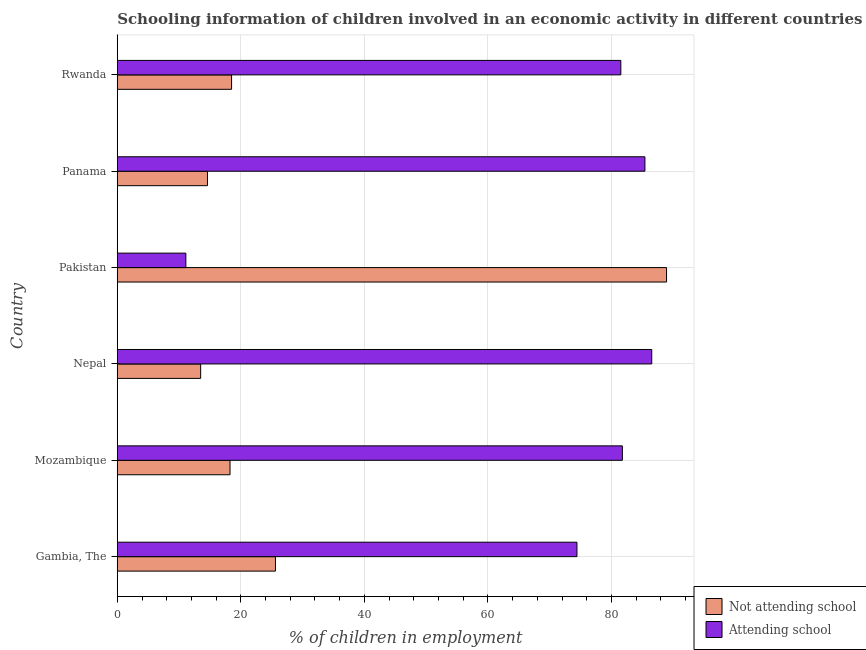How many different coloured bars are there?
Your response must be concise. 2. How many groups of bars are there?
Your response must be concise. 6. What is the label of the 1st group of bars from the top?
Offer a very short reply. Rwanda. Across all countries, what is the maximum percentage of employed children who are attending school?
Make the answer very short. 86.51. Across all countries, what is the minimum percentage of employed children who are not attending school?
Ensure brevity in your answer.  13.49. What is the total percentage of employed children who are attending school in the graph?
Provide a succinct answer. 420.66. What is the difference between the percentage of employed children who are attending school in Gambia, The and that in Mozambique?
Your answer should be compact. -7.35. What is the average percentage of employed children who are not attending school per country?
Ensure brevity in your answer.  29.89. What is the difference between the percentage of employed children who are attending school and percentage of employed children who are not attending school in Gambia, The?
Your answer should be very brief. 48.8. In how many countries, is the percentage of employed children who are not attending school greater than 52 %?
Provide a short and direct response. 1. What is the ratio of the percentage of employed children who are attending school in Gambia, The to that in Panama?
Offer a terse response. 0.87. Is the percentage of employed children who are attending school in Gambia, The less than that in Panama?
Your answer should be compact. Yes. Is the difference between the percentage of employed children who are attending school in Gambia, The and Rwanda greater than the difference between the percentage of employed children who are not attending school in Gambia, The and Rwanda?
Your answer should be compact. No. What is the difference between the highest and the second highest percentage of employed children who are attending school?
Your answer should be compact. 1.11. What is the difference between the highest and the lowest percentage of employed children who are attending school?
Provide a short and direct response. 75.41. Is the sum of the percentage of employed children who are attending school in Mozambique and Rwanda greater than the maximum percentage of employed children who are not attending school across all countries?
Your answer should be compact. Yes. What does the 2nd bar from the top in Panama represents?
Keep it short and to the point. Not attending school. What does the 2nd bar from the bottom in Nepal represents?
Provide a succinct answer. Attending school. How many bars are there?
Provide a short and direct response. 12. Are all the bars in the graph horizontal?
Your response must be concise. Yes. How many countries are there in the graph?
Your response must be concise. 6. What is the difference between two consecutive major ticks on the X-axis?
Provide a short and direct response. 20. Does the graph contain any zero values?
Provide a short and direct response. No. Where does the legend appear in the graph?
Keep it short and to the point. Bottom right. How are the legend labels stacked?
Keep it short and to the point. Vertical. What is the title of the graph?
Your response must be concise. Schooling information of children involved in an economic activity in different countries. Does "Non-residents" appear as one of the legend labels in the graph?
Offer a terse response. No. What is the label or title of the X-axis?
Provide a succinct answer. % of children in employment. What is the label or title of the Y-axis?
Offer a terse response. Country. What is the % of children in employment in Not attending school in Gambia, The?
Keep it short and to the point. 25.6. What is the % of children in employment in Attending school in Gambia, The?
Your response must be concise. 74.4. What is the % of children in employment in Not attending school in Mozambique?
Your answer should be compact. 18.25. What is the % of children in employment of Attending school in Mozambique?
Give a very brief answer. 81.75. What is the % of children in employment of Not attending school in Nepal?
Offer a very short reply. 13.49. What is the % of children in employment of Attending school in Nepal?
Keep it short and to the point. 86.51. What is the % of children in employment in Not attending school in Pakistan?
Keep it short and to the point. 88.9. What is the % of children in employment in Attending school in Panama?
Offer a very short reply. 85.4. What is the % of children in employment of Not attending school in Rwanda?
Provide a short and direct response. 18.5. What is the % of children in employment in Attending school in Rwanda?
Your answer should be compact. 81.5. Across all countries, what is the maximum % of children in employment of Not attending school?
Give a very brief answer. 88.9. Across all countries, what is the maximum % of children in employment in Attending school?
Your response must be concise. 86.51. Across all countries, what is the minimum % of children in employment in Not attending school?
Give a very brief answer. 13.49. What is the total % of children in employment of Not attending school in the graph?
Your answer should be compact. 179.34. What is the total % of children in employment of Attending school in the graph?
Your answer should be very brief. 420.66. What is the difference between the % of children in employment in Not attending school in Gambia, The and that in Mozambique?
Offer a very short reply. 7.35. What is the difference between the % of children in employment in Attending school in Gambia, The and that in Mozambique?
Your response must be concise. -7.35. What is the difference between the % of children in employment in Not attending school in Gambia, The and that in Nepal?
Give a very brief answer. 12.11. What is the difference between the % of children in employment in Attending school in Gambia, The and that in Nepal?
Offer a terse response. -12.11. What is the difference between the % of children in employment of Not attending school in Gambia, The and that in Pakistan?
Offer a terse response. -63.3. What is the difference between the % of children in employment of Attending school in Gambia, The and that in Pakistan?
Provide a short and direct response. 63.3. What is the difference between the % of children in employment of Not attending school in Gambia, The and that in Rwanda?
Make the answer very short. 7.1. What is the difference between the % of children in employment in Not attending school in Mozambique and that in Nepal?
Make the answer very short. 4.75. What is the difference between the % of children in employment in Attending school in Mozambique and that in Nepal?
Ensure brevity in your answer.  -4.75. What is the difference between the % of children in employment in Not attending school in Mozambique and that in Pakistan?
Your answer should be very brief. -70.65. What is the difference between the % of children in employment of Attending school in Mozambique and that in Pakistan?
Provide a short and direct response. 70.65. What is the difference between the % of children in employment of Not attending school in Mozambique and that in Panama?
Provide a short and direct response. 3.65. What is the difference between the % of children in employment of Attending school in Mozambique and that in Panama?
Provide a succinct answer. -3.65. What is the difference between the % of children in employment of Not attending school in Mozambique and that in Rwanda?
Ensure brevity in your answer.  -0.25. What is the difference between the % of children in employment in Attending school in Mozambique and that in Rwanda?
Offer a terse response. 0.25. What is the difference between the % of children in employment of Not attending school in Nepal and that in Pakistan?
Offer a terse response. -75.41. What is the difference between the % of children in employment in Attending school in Nepal and that in Pakistan?
Your answer should be very brief. 75.41. What is the difference between the % of children in employment of Not attending school in Nepal and that in Panama?
Ensure brevity in your answer.  -1.11. What is the difference between the % of children in employment in Attending school in Nepal and that in Panama?
Provide a succinct answer. 1.11. What is the difference between the % of children in employment in Not attending school in Nepal and that in Rwanda?
Your answer should be compact. -5.01. What is the difference between the % of children in employment in Attending school in Nepal and that in Rwanda?
Your response must be concise. 5.01. What is the difference between the % of children in employment in Not attending school in Pakistan and that in Panama?
Ensure brevity in your answer.  74.3. What is the difference between the % of children in employment in Attending school in Pakistan and that in Panama?
Your response must be concise. -74.3. What is the difference between the % of children in employment of Not attending school in Pakistan and that in Rwanda?
Your response must be concise. 70.4. What is the difference between the % of children in employment of Attending school in Pakistan and that in Rwanda?
Keep it short and to the point. -70.4. What is the difference between the % of children in employment in Not attending school in Panama and that in Rwanda?
Provide a succinct answer. -3.9. What is the difference between the % of children in employment of Attending school in Panama and that in Rwanda?
Your response must be concise. 3.9. What is the difference between the % of children in employment of Not attending school in Gambia, The and the % of children in employment of Attending school in Mozambique?
Offer a terse response. -56.15. What is the difference between the % of children in employment in Not attending school in Gambia, The and the % of children in employment in Attending school in Nepal?
Your answer should be compact. -60.91. What is the difference between the % of children in employment of Not attending school in Gambia, The and the % of children in employment of Attending school in Pakistan?
Ensure brevity in your answer.  14.5. What is the difference between the % of children in employment of Not attending school in Gambia, The and the % of children in employment of Attending school in Panama?
Offer a terse response. -59.8. What is the difference between the % of children in employment of Not attending school in Gambia, The and the % of children in employment of Attending school in Rwanda?
Offer a terse response. -55.9. What is the difference between the % of children in employment in Not attending school in Mozambique and the % of children in employment in Attending school in Nepal?
Your answer should be very brief. -68.26. What is the difference between the % of children in employment of Not attending school in Mozambique and the % of children in employment of Attending school in Pakistan?
Make the answer very short. 7.15. What is the difference between the % of children in employment of Not attending school in Mozambique and the % of children in employment of Attending school in Panama?
Your answer should be compact. -67.15. What is the difference between the % of children in employment of Not attending school in Mozambique and the % of children in employment of Attending school in Rwanda?
Your response must be concise. -63.25. What is the difference between the % of children in employment in Not attending school in Nepal and the % of children in employment in Attending school in Pakistan?
Offer a terse response. 2.39. What is the difference between the % of children in employment of Not attending school in Nepal and the % of children in employment of Attending school in Panama?
Provide a succinct answer. -71.91. What is the difference between the % of children in employment in Not attending school in Nepal and the % of children in employment in Attending school in Rwanda?
Keep it short and to the point. -68.01. What is the difference between the % of children in employment of Not attending school in Panama and the % of children in employment of Attending school in Rwanda?
Your answer should be compact. -66.9. What is the average % of children in employment in Not attending school per country?
Provide a succinct answer. 29.89. What is the average % of children in employment in Attending school per country?
Provide a short and direct response. 70.11. What is the difference between the % of children in employment in Not attending school and % of children in employment in Attending school in Gambia, The?
Your answer should be very brief. -48.8. What is the difference between the % of children in employment in Not attending school and % of children in employment in Attending school in Mozambique?
Make the answer very short. -63.5. What is the difference between the % of children in employment in Not attending school and % of children in employment in Attending school in Nepal?
Keep it short and to the point. -73.01. What is the difference between the % of children in employment in Not attending school and % of children in employment in Attending school in Pakistan?
Provide a succinct answer. 77.8. What is the difference between the % of children in employment of Not attending school and % of children in employment of Attending school in Panama?
Provide a short and direct response. -70.8. What is the difference between the % of children in employment in Not attending school and % of children in employment in Attending school in Rwanda?
Give a very brief answer. -63. What is the ratio of the % of children in employment of Not attending school in Gambia, The to that in Mozambique?
Keep it short and to the point. 1.4. What is the ratio of the % of children in employment of Attending school in Gambia, The to that in Mozambique?
Provide a short and direct response. 0.91. What is the ratio of the % of children in employment in Not attending school in Gambia, The to that in Nepal?
Ensure brevity in your answer.  1.9. What is the ratio of the % of children in employment of Attending school in Gambia, The to that in Nepal?
Your answer should be compact. 0.86. What is the ratio of the % of children in employment of Not attending school in Gambia, The to that in Pakistan?
Offer a terse response. 0.29. What is the ratio of the % of children in employment in Attending school in Gambia, The to that in Pakistan?
Your answer should be very brief. 6.7. What is the ratio of the % of children in employment in Not attending school in Gambia, The to that in Panama?
Keep it short and to the point. 1.75. What is the ratio of the % of children in employment of Attending school in Gambia, The to that in Panama?
Provide a succinct answer. 0.87. What is the ratio of the % of children in employment of Not attending school in Gambia, The to that in Rwanda?
Give a very brief answer. 1.38. What is the ratio of the % of children in employment in Attending school in Gambia, The to that in Rwanda?
Offer a terse response. 0.91. What is the ratio of the % of children in employment of Not attending school in Mozambique to that in Nepal?
Your response must be concise. 1.35. What is the ratio of the % of children in employment in Attending school in Mozambique to that in Nepal?
Ensure brevity in your answer.  0.94. What is the ratio of the % of children in employment of Not attending school in Mozambique to that in Pakistan?
Provide a succinct answer. 0.21. What is the ratio of the % of children in employment of Attending school in Mozambique to that in Pakistan?
Give a very brief answer. 7.37. What is the ratio of the % of children in employment in Not attending school in Mozambique to that in Panama?
Give a very brief answer. 1.25. What is the ratio of the % of children in employment of Attending school in Mozambique to that in Panama?
Ensure brevity in your answer.  0.96. What is the ratio of the % of children in employment in Not attending school in Mozambique to that in Rwanda?
Provide a succinct answer. 0.99. What is the ratio of the % of children in employment in Not attending school in Nepal to that in Pakistan?
Offer a terse response. 0.15. What is the ratio of the % of children in employment of Attending school in Nepal to that in Pakistan?
Ensure brevity in your answer.  7.79. What is the ratio of the % of children in employment of Not attending school in Nepal to that in Panama?
Offer a very short reply. 0.92. What is the ratio of the % of children in employment of Not attending school in Nepal to that in Rwanda?
Offer a terse response. 0.73. What is the ratio of the % of children in employment in Attending school in Nepal to that in Rwanda?
Your answer should be compact. 1.06. What is the ratio of the % of children in employment in Not attending school in Pakistan to that in Panama?
Provide a short and direct response. 6.09. What is the ratio of the % of children in employment of Attending school in Pakistan to that in Panama?
Provide a short and direct response. 0.13. What is the ratio of the % of children in employment in Not attending school in Pakistan to that in Rwanda?
Give a very brief answer. 4.81. What is the ratio of the % of children in employment of Attending school in Pakistan to that in Rwanda?
Ensure brevity in your answer.  0.14. What is the ratio of the % of children in employment of Not attending school in Panama to that in Rwanda?
Your answer should be very brief. 0.79. What is the ratio of the % of children in employment in Attending school in Panama to that in Rwanda?
Make the answer very short. 1.05. What is the difference between the highest and the second highest % of children in employment of Not attending school?
Provide a short and direct response. 63.3. What is the difference between the highest and the second highest % of children in employment in Attending school?
Keep it short and to the point. 1.11. What is the difference between the highest and the lowest % of children in employment of Not attending school?
Offer a terse response. 75.41. What is the difference between the highest and the lowest % of children in employment in Attending school?
Provide a short and direct response. 75.41. 